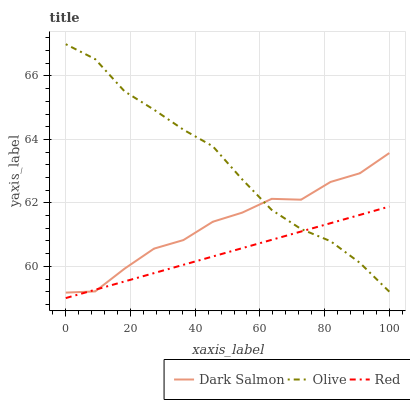Does Dark Salmon have the minimum area under the curve?
Answer yes or no. No. Does Dark Salmon have the maximum area under the curve?
Answer yes or no. No. Is Dark Salmon the smoothest?
Answer yes or no. No. Is Red the roughest?
Answer yes or no. No. Does Dark Salmon have the lowest value?
Answer yes or no. No. Does Dark Salmon have the highest value?
Answer yes or no. No. 